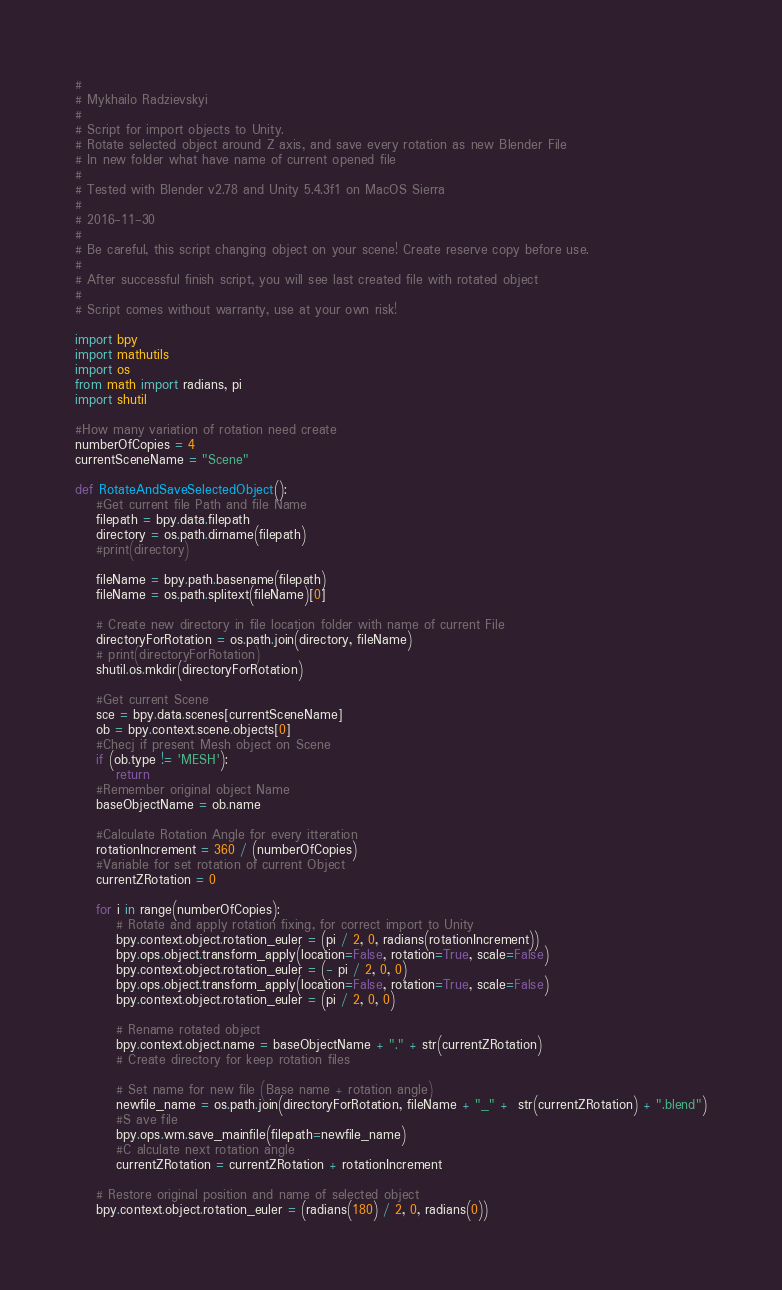Convert code to text. <code><loc_0><loc_0><loc_500><loc_500><_Python_>#
# Mykhailo Radzievskyi
#
# Script for import objects to Unity.
# Rotate selected object around Z axis, and save every rotation as new Blender File
# In new folder what have name of current opened file
#
# Tested with Blender v2.78 and Unity 5.4.3f1 on MacOS Sierra
#
# 2016-11-30
#
# Be careful, this script changing object on your scene! Create reserve copy before use.
#
# After successful finish script, you will see last created file with rotated object
#
# Script comes without warranty, use at your own risk!

import bpy
import mathutils
import os
from math import radians, pi
import shutil

#How many variation of rotation need create
numberOfCopies = 4
currentSceneName = "Scene"

def RotateAndSaveSelectedObject():
    #Get current file Path and file Name
    filepath = bpy.data.filepath
    directory = os.path.dirname(filepath)
    #print(directory)
    
    fileName = bpy.path.basename(filepath)
    fileName = os.path.splitext(fileName)[0]
    
    # Create new directory in file location folder with name of current File
    directoryForRotation = os.path.join(directory, fileName)
    # print(directoryForRotation)
    shutil.os.mkdir(directoryForRotation)
    
    #Get current Scene
    sce = bpy.data.scenes[currentSceneName]
    ob = bpy.context.scene.objects[0]
    #Checj if present Mesh object on Scene
    if (ob.type != 'MESH'):
        return
    #Remember original object Name
    baseObjectName = ob.name 

    #Calculate Rotation Angle for every itteration
    rotationIncrement = 360 / (numberOfCopies)
    #Variable for set rotation of current Object
    currentZRotation = 0
    
    for i in range(numberOfCopies):
        # Rotate and apply rotation fixing, for correct import to Unity
        bpy.context.object.rotation_euler = (pi / 2, 0, radians(rotationIncrement))
        bpy.ops.object.transform_apply(location=False, rotation=True, scale=False)
        bpy.context.object.rotation_euler = (- pi / 2, 0, 0)
        bpy.ops.object.transform_apply(location=False, rotation=True, scale=False)
        bpy.context.object.rotation_euler = (pi / 2, 0, 0)
        
        # Rename rotated object
        bpy.context.object.name = baseObjectName + "." + str(currentZRotation)
        # Create directory for keep rotation files

        # Set name for new file (Base name + rotation angle)
        newfile_name = os.path.join(directoryForRotation, fileName + "_" +  str(currentZRotation) + ".blend")
        #S ave file
        bpy.ops.wm.save_mainfile(filepath=newfile_name)
        #C alculate next rotation angle
        currentZRotation = currentZRotation + rotationIncrement
    
    # Restore original position and name of selected object    
    bpy.context.object.rotation_euler = (radians(180) / 2, 0, radians(0))</code> 